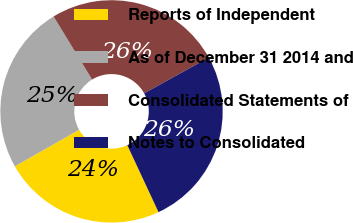Convert chart to OTSL. <chart><loc_0><loc_0><loc_500><loc_500><pie_chart><fcel>Reports of Independent<fcel>As of December 31 2014 and<fcel>Consolidated Statements of<fcel>Notes to Consolidated<nl><fcel>23.72%<fcel>24.51%<fcel>25.69%<fcel>26.09%<nl></chart> 